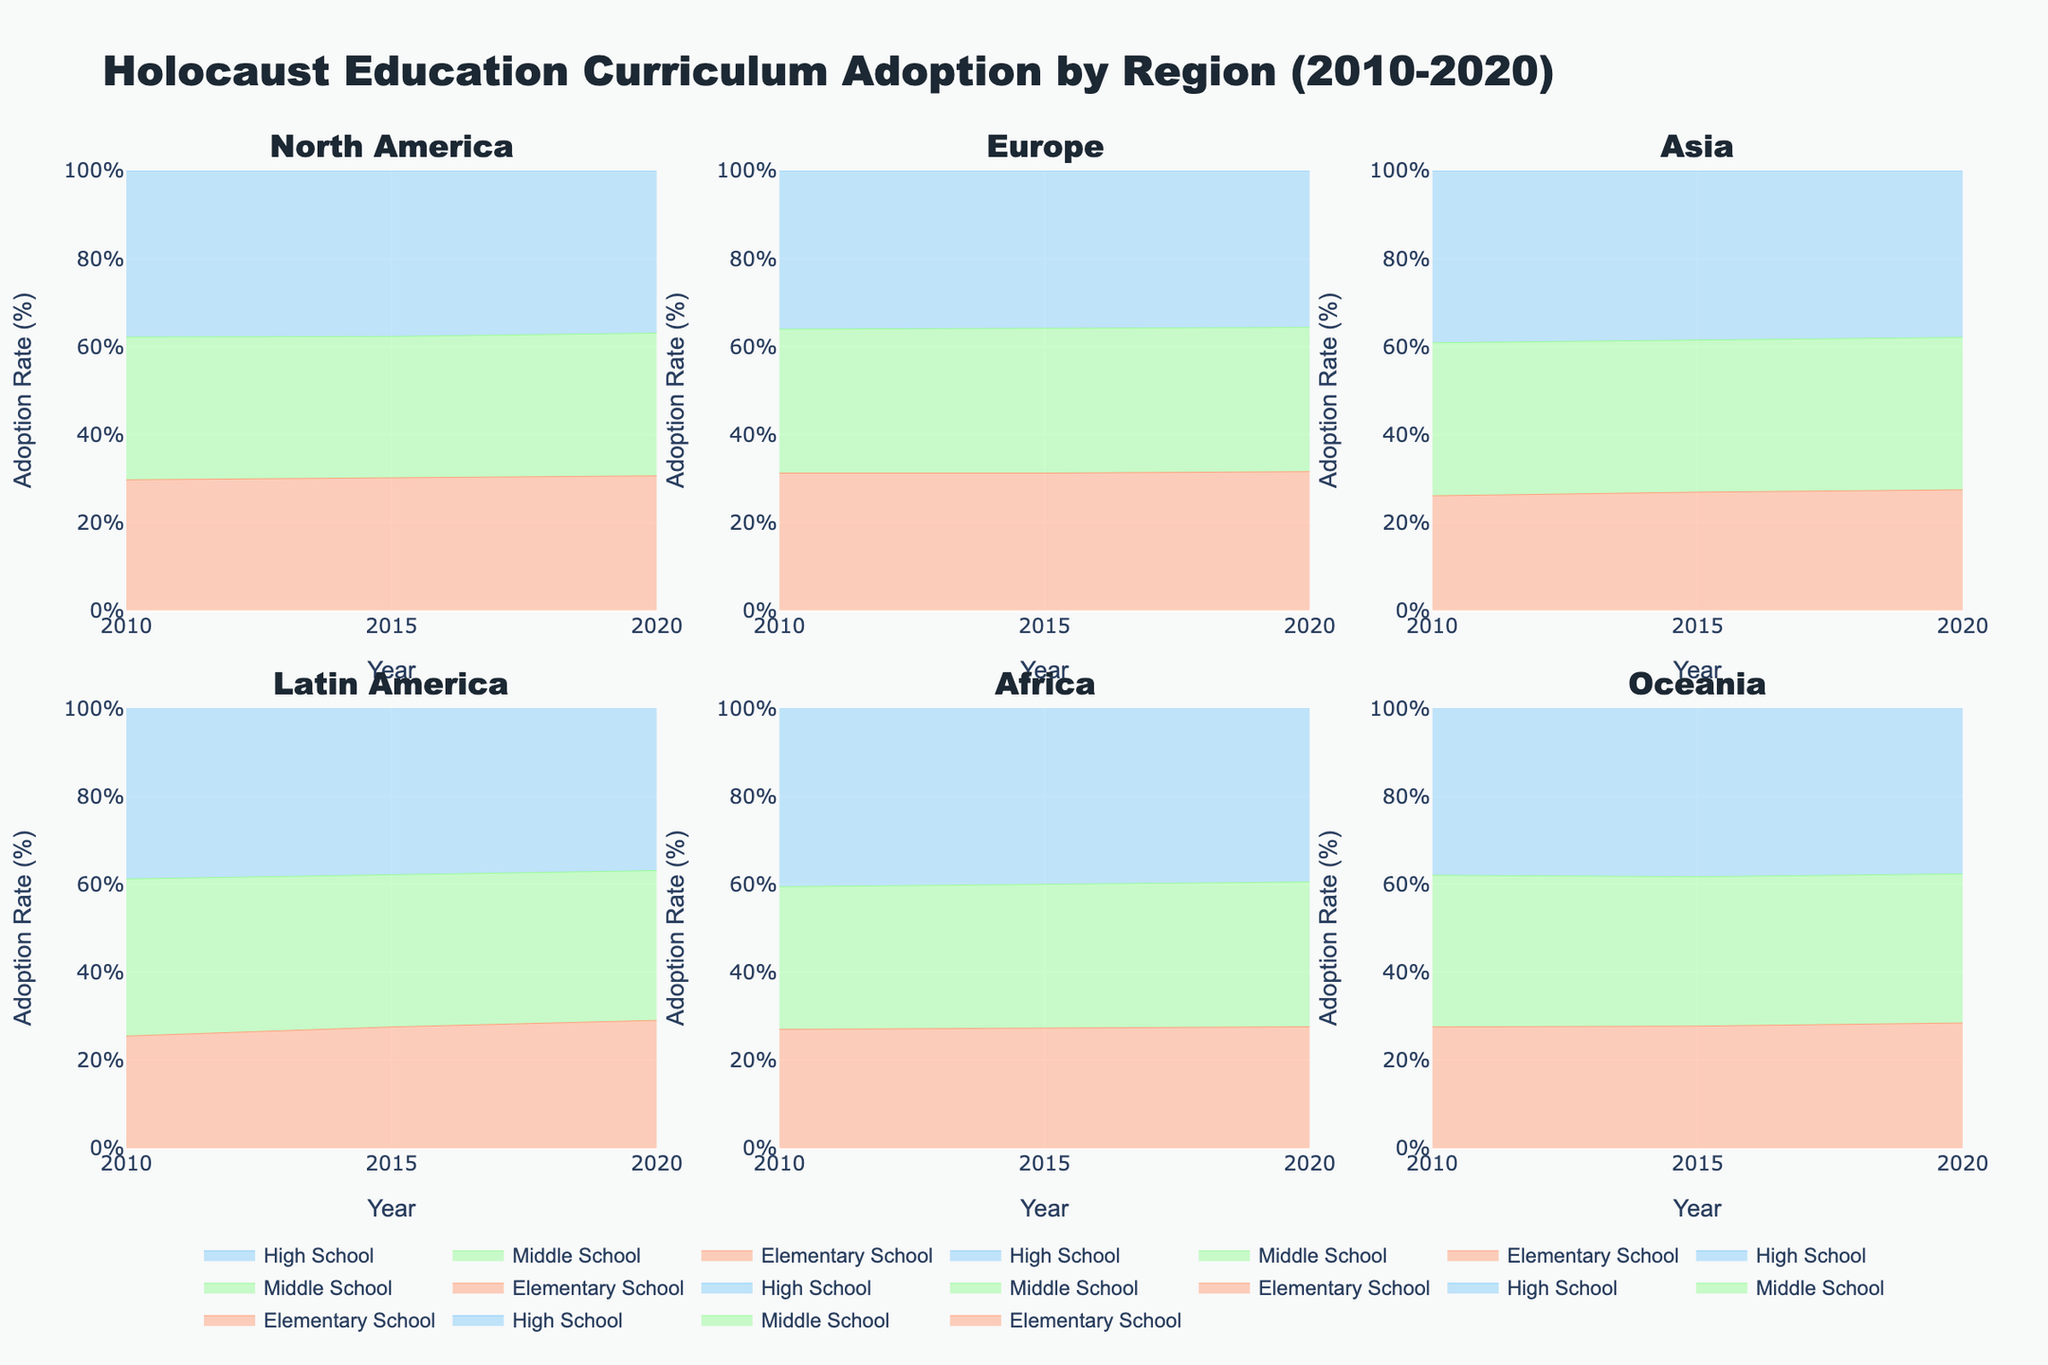Which region shows the highest adoption rate for Holocaust education curricula in high schools by 2020? In the subplot for each region, locate the high school adoption rates for the year 2020. Compare the peaks of these values across all regions.
Answer: Europe How did the adoption rate in North America for middle schools change from 2010 to 2020? Locate the middle school adoption rates for North America for the years 2010 and 2020. Subtract the 2010 rate from the 2020 rate.
Answer: Increased by 12% Which educational level in Asia shows the greatest increase in curriculum adoption rate from 2010 to 2020? Locate the adoption rates for each educational level in Asia for the years 2010 and 2020. Calculate the difference for each level and find the highest increase.
Answer: High School What is the comparative increase in adoption rates between elementary and high school levels in Europe from 2010 to 2020? Locate the adoption rates for elementary and high school levels in Europe for 2010 and 2020. Calculate the respective increases and compare the two values.
Answer: Elementary: 13%, High School: 13% Which region had the lowest adoption rate for elementary schools in 2015? Locate the elementary school adoption rates for the year 2015 across all regions and identify the lowest value.
Answer: Africa Between 2010 and 2020, which region had the largest percentage increase in middle school adoption rates? Locate the middle school adoption rates for 2010 and 2020 across all regions and calculate the percentage increase for each region. Compare these increases to identify the largest.
Answer: Africa In Latin America, how did the adoption rates change for high schools between 2015 and 2020? Locate the high school adoption rates for Latin America for the years 2015 and 2020. Subtract the 2015 rate from the 2020 rate.
Answer: Increased by 8% Compare the adoption rates for Holocaust education curricula in high schools between North America and Oceania in 2020. Which region had a higher rate? Locate the high school adoption rates for North America and Oceania for the year 2020 in their respective subplots. Compare these values to determine which is higher.
Answer: North America What is the average adoption rate for Holocaust education curricula in middle schools across all regions in 2020? Locate the middle school adoption rates for 2020 across all regions. Sum these rates and divide by the number of regions.
Answer: 57% Which region shows the most consistent increase in adoption rates across all educational levels from 2010 to 2020? Examine the trend of adoption rates across all educational levels for each region. Identify the region where all levels show a steady increase without fluctuations.
Answer: Europe 